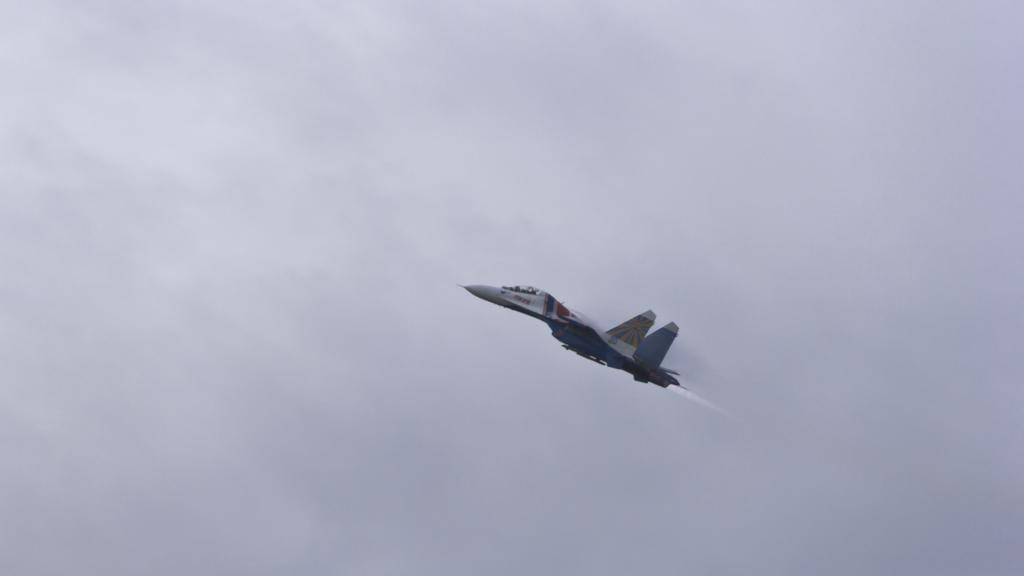What type of aircraft is in the image? There is a fighter jet plane in the image. What is the plane doing in the image? The plane is flying in the air. What can be seen in the background of the image? There is sky visible in the image, and clouds are present in the sky. What type of dress is the geese wearing in the image? There are no geese or dresses present in the image; it features a fighter jet plane flying in the sky. 